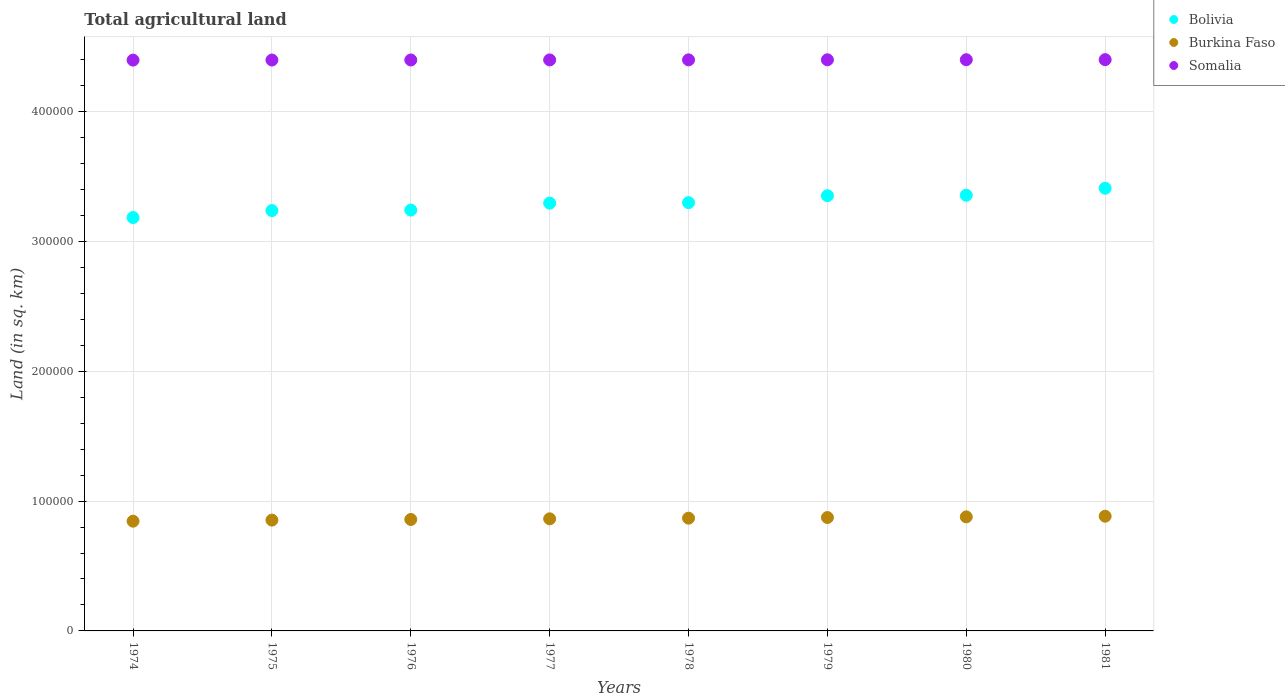How many different coloured dotlines are there?
Make the answer very short. 3. What is the total agricultural land in Somalia in 1974?
Make the answer very short. 4.40e+05. Across all years, what is the maximum total agricultural land in Bolivia?
Make the answer very short. 3.41e+05. Across all years, what is the minimum total agricultural land in Somalia?
Offer a very short reply. 4.40e+05. In which year was the total agricultural land in Somalia maximum?
Keep it short and to the point. 1981. In which year was the total agricultural land in Somalia minimum?
Ensure brevity in your answer.  1974. What is the total total agricultural land in Burkina Faso in the graph?
Offer a terse response. 6.92e+05. What is the difference between the total agricultural land in Somalia in 1975 and that in 1977?
Offer a very short reply. -100. What is the difference between the total agricultural land in Somalia in 1975 and the total agricultural land in Burkina Faso in 1974?
Make the answer very short. 3.55e+05. What is the average total agricultural land in Bolivia per year?
Your answer should be very brief. 3.30e+05. In the year 1978, what is the difference between the total agricultural land in Bolivia and total agricultural land in Somalia?
Provide a succinct answer. -1.10e+05. In how many years, is the total agricultural land in Somalia greater than 80000 sq.km?
Your answer should be compact. 8. What is the ratio of the total agricultural land in Somalia in 1975 to that in 1978?
Your response must be concise. 1. Is the difference between the total agricultural land in Bolivia in 1976 and 1980 greater than the difference between the total agricultural land in Somalia in 1976 and 1980?
Provide a short and direct response. No. What is the difference between the highest and the second highest total agricultural land in Bolivia?
Ensure brevity in your answer.  5370. What is the difference between the highest and the lowest total agricultural land in Burkina Faso?
Your answer should be very brief. 3820. Is it the case that in every year, the sum of the total agricultural land in Somalia and total agricultural land in Burkina Faso  is greater than the total agricultural land in Bolivia?
Your answer should be very brief. Yes. Is the total agricultural land in Bolivia strictly greater than the total agricultural land in Burkina Faso over the years?
Offer a very short reply. Yes. How many dotlines are there?
Keep it short and to the point. 3. How many years are there in the graph?
Your answer should be compact. 8. Are the values on the major ticks of Y-axis written in scientific E-notation?
Your answer should be compact. No. Does the graph contain any zero values?
Your answer should be very brief. No. How many legend labels are there?
Offer a very short reply. 3. What is the title of the graph?
Your response must be concise. Total agricultural land. Does "Argentina" appear as one of the legend labels in the graph?
Provide a succinct answer. No. What is the label or title of the Y-axis?
Provide a succinct answer. Land (in sq. km). What is the Land (in sq. km) of Bolivia in 1974?
Ensure brevity in your answer.  3.18e+05. What is the Land (in sq. km) of Burkina Faso in 1974?
Your answer should be compact. 8.45e+04. What is the Land (in sq. km) of Somalia in 1974?
Keep it short and to the point. 4.40e+05. What is the Land (in sq. km) of Bolivia in 1975?
Your answer should be compact. 3.24e+05. What is the Land (in sq. km) in Burkina Faso in 1975?
Your response must be concise. 8.54e+04. What is the Land (in sq. km) of Somalia in 1975?
Offer a terse response. 4.40e+05. What is the Land (in sq. km) of Bolivia in 1976?
Provide a short and direct response. 3.24e+05. What is the Land (in sq. km) of Burkina Faso in 1976?
Your answer should be compact. 8.58e+04. What is the Land (in sq. km) in Somalia in 1976?
Provide a succinct answer. 4.40e+05. What is the Land (in sq. km) in Bolivia in 1977?
Your answer should be very brief. 3.30e+05. What is the Land (in sq. km) of Burkina Faso in 1977?
Give a very brief answer. 8.64e+04. What is the Land (in sq. km) of Somalia in 1977?
Make the answer very short. 4.40e+05. What is the Land (in sq. km) in Bolivia in 1978?
Your answer should be compact. 3.30e+05. What is the Land (in sq. km) of Burkina Faso in 1978?
Offer a very short reply. 8.68e+04. What is the Land (in sq. km) in Somalia in 1978?
Provide a succinct answer. 4.40e+05. What is the Land (in sq. km) of Bolivia in 1979?
Keep it short and to the point. 3.35e+05. What is the Land (in sq. km) of Burkina Faso in 1979?
Offer a terse response. 8.74e+04. What is the Land (in sq. km) of Somalia in 1979?
Offer a very short reply. 4.40e+05. What is the Land (in sq. km) in Bolivia in 1980?
Give a very brief answer. 3.36e+05. What is the Land (in sq. km) of Burkina Faso in 1980?
Ensure brevity in your answer.  8.78e+04. What is the Land (in sq. km) in Bolivia in 1981?
Your answer should be very brief. 3.41e+05. What is the Land (in sq. km) in Burkina Faso in 1981?
Your answer should be very brief. 8.84e+04. What is the Land (in sq. km) of Somalia in 1981?
Offer a terse response. 4.40e+05. Across all years, what is the maximum Land (in sq. km) in Bolivia?
Offer a terse response. 3.41e+05. Across all years, what is the maximum Land (in sq. km) in Burkina Faso?
Provide a short and direct response. 8.84e+04. Across all years, what is the maximum Land (in sq. km) in Somalia?
Offer a terse response. 4.40e+05. Across all years, what is the minimum Land (in sq. km) of Bolivia?
Give a very brief answer. 3.18e+05. Across all years, what is the minimum Land (in sq. km) in Burkina Faso?
Ensure brevity in your answer.  8.45e+04. Across all years, what is the minimum Land (in sq. km) of Somalia?
Your response must be concise. 4.40e+05. What is the total Land (in sq. km) in Bolivia in the graph?
Provide a short and direct response. 2.64e+06. What is the total Land (in sq. km) of Burkina Faso in the graph?
Keep it short and to the point. 6.92e+05. What is the total Land (in sq. km) in Somalia in the graph?
Provide a short and direct response. 3.52e+06. What is the difference between the Land (in sq. km) in Bolivia in 1974 and that in 1975?
Your answer should be compact. -5370. What is the difference between the Land (in sq. km) of Burkina Faso in 1974 and that in 1975?
Give a very brief answer. -830. What is the difference between the Land (in sq. km) of Bolivia in 1974 and that in 1976?
Keep it short and to the point. -5730. What is the difference between the Land (in sq. km) in Burkina Faso in 1974 and that in 1976?
Keep it short and to the point. -1320. What is the difference between the Land (in sq. km) of Somalia in 1974 and that in 1976?
Keep it short and to the point. -100. What is the difference between the Land (in sq. km) in Bolivia in 1974 and that in 1977?
Provide a short and direct response. -1.11e+04. What is the difference between the Land (in sq. km) of Burkina Faso in 1974 and that in 1977?
Your answer should be very brief. -1820. What is the difference between the Land (in sq. km) in Somalia in 1974 and that in 1977?
Provide a succinct answer. -150. What is the difference between the Land (in sq. km) in Bolivia in 1974 and that in 1978?
Your answer should be very brief. -1.15e+04. What is the difference between the Land (in sq. km) of Burkina Faso in 1974 and that in 1978?
Provide a short and direct response. -2320. What is the difference between the Land (in sq. km) of Somalia in 1974 and that in 1978?
Your answer should be compact. -200. What is the difference between the Land (in sq. km) of Bolivia in 1974 and that in 1979?
Offer a terse response. -1.68e+04. What is the difference between the Land (in sq. km) in Burkina Faso in 1974 and that in 1979?
Provide a short and direct response. -2820. What is the difference between the Land (in sq. km) in Somalia in 1974 and that in 1979?
Your answer should be very brief. -250. What is the difference between the Land (in sq. km) in Bolivia in 1974 and that in 1980?
Provide a short and direct response. -1.72e+04. What is the difference between the Land (in sq. km) of Burkina Faso in 1974 and that in 1980?
Keep it short and to the point. -3320. What is the difference between the Land (in sq. km) in Somalia in 1974 and that in 1980?
Offer a very short reply. -300. What is the difference between the Land (in sq. km) in Bolivia in 1974 and that in 1981?
Offer a very short reply. -2.26e+04. What is the difference between the Land (in sq. km) in Burkina Faso in 1974 and that in 1981?
Provide a short and direct response. -3820. What is the difference between the Land (in sq. km) of Somalia in 1974 and that in 1981?
Your response must be concise. -350. What is the difference between the Land (in sq. km) of Bolivia in 1975 and that in 1976?
Give a very brief answer. -360. What is the difference between the Land (in sq. km) of Burkina Faso in 1975 and that in 1976?
Offer a terse response. -490. What is the difference between the Land (in sq. km) of Bolivia in 1975 and that in 1977?
Make the answer very short. -5730. What is the difference between the Land (in sq. km) of Burkina Faso in 1975 and that in 1977?
Offer a terse response. -990. What is the difference between the Land (in sq. km) of Somalia in 1975 and that in 1977?
Offer a very short reply. -100. What is the difference between the Land (in sq. km) in Bolivia in 1975 and that in 1978?
Make the answer very short. -6090. What is the difference between the Land (in sq. km) in Burkina Faso in 1975 and that in 1978?
Your answer should be very brief. -1490. What is the difference between the Land (in sq. km) of Somalia in 1975 and that in 1978?
Your answer should be compact. -150. What is the difference between the Land (in sq. km) of Bolivia in 1975 and that in 1979?
Give a very brief answer. -1.14e+04. What is the difference between the Land (in sq. km) in Burkina Faso in 1975 and that in 1979?
Give a very brief answer. -1990. What is the difference between the Land (in sq. km) in Somalia in 1975 and that in 1979?
Your answer should be very brief. -200. What is the difference between the Land (in sq. km) in Bolivia in 1975 and that in 1980?
Your answer should be very brief. -1.18e+04. What is the difference between the Land (in sq. km) of Burkina Faso in 1975 and that in 1980?
Give a very brief answer. -2490. What is the difference between the Land (in sq. km) of Somalia in 1975 and that in 1980?
Give a very brief answer. -250. What is the difference between the Land (in sq. km) of Bolivia in 1975 and that in 1981?
Your answer should be compact. -1.72e+04. What is the difference between the Land (in sq. km) of Burkina Faso in 1975 and that in 1981?
Give a very brief answer. -2990. What is the difference between the Land (in sq. km) of Somalia in 1975 and that in 1981?
Ensure brevity in your answer.  -300. What is the difference between the Land (in sq. km) in Bolivia in 1976 and that in 1977?
Provide a short and direct response. -5370. What is the difference between the Land (in sq. km) of Burkina Faso in 1976 and that in 1977?
Ensure brevity in your answer.  -500. What is the difference between the Land (in sq. km) of Bolivia in 1976 and that in 1978?
Your answer should be very brief. -5730. What is the difference between the Land (in sq. km) of Burkina Faso in 1976 and that in 1978?
Offer a terse response. -1000. What is the difference between the Land (in sq. km) in Somalia in 1976 and that in 1978?
Make the answer very short. -100. What is the difference between the Land (in sq. km) of Bolivia in 1976 and that in 1979?
Offer a terse response. -1.11e+04. What is the difference between the Land (in sq. km) in Burkina Faso in 1976 and that in 1979?
Offer a very short reply. -1500. What is the difference between the Land (in sq. km) of Somalia in 1976 and that in 1979?
Provide a short and direct response. -150. What is the difference between the Land (in sq. km) of Bolivia in 1976 and that in 1980?
Make the answer very short. -1.15e+04. What is the difference between the Land (in sq. km) in Burkina Faso in 1976 and that in 1980?
Your response must be concise. -2000. What is the difference between the Land (in sq. km) in Somalia in 1976 and that in 1980?
Ensure brevity in your answer.  -200. What is the difference between the Land (in sq. km) in Bolivia in 1976 and that in 1981?
Keep it short and to the point. -1.68e+04. What is the difference between the Land (in sq. km) of Burkina Faso in 1976 and that in 1981?
Your response must be concise. -2500. What is the difference between the Land (in sq. km) of Somalia in 1976 and that in 1981?
Give a very brief answer. -250. What is the difference between the Land (in sq. km) of Bolivia in 1977 and that in 1978?
Provide a succinct answer. -360. What is the difference between the Land (in sq. km) in Burkina Faso in 1977 and that in 1978?
Make the answer very short. -500. What is the difference between the Land (in sq. km) of Somalia in 1977 and that in 1978?
Give a very brief answer. -50. What is the difference between the Land (in sq. km) of Bolivia in 1977 and that in 1979?
Offer a very short reply. -5720. What is the difference between the Land (in sq. km) of Burkina Faso in 1977 and that in 1979?
Offer a very short reply. -1000. What is the difference between the Land (in sq. km) in Somalia in 1977 and that in 1979?
Provide a short and direct response. -100. What is the difference between the Land (in sq. km) of Bolivia in 1977 and that in 1980?
Your response must be concise. -6090. What is the difference between the Land (in sq. km) of Burkina Faso in 1977 and that in 1980?
Give a very brief answer. -1500. What is the difference between the Land (in sq. km) of Somalia in 1977 and that in 1980?
Keep it short and to the point. -150. What is the difference between the Land (in sq. km) in Bolivia in 1977 and that in 1981?
Your answer should be compact. -1.15e+04. What is the difference between the Land (in sq. km) in Burkina Faso in 1977 and that in 1981?
Ensure brevity in your answer.  -2000. What is the difference between the Land (in sq. km) in Somalia in 1977 and that in 1981?
Offer a very short reply. -200. What is the difference between the Land (in sq. km) of Bolivia in 1978 and that in 1979?
Ensure brevity in your answer.  -5360. What is the difference between the Land (in sq. km) in Burkina Faso in 1978 and that in 1979?
Your response must be concise. -500. What is the difference between the Land (in sq. km) in Bolivia in 1978 and that in 1980?
Provide a short and direct response. -5730. What is the difference between the Land (in sq. km) in Burkina Faso in 1978 and that in 1980?
Ensure brevity in your answer.  -1000. What is the difference between the Land (in sq. km) of Somalia in 1978 and that in 1980?
Your answer should be very brief. -100. What is the difference between the Land (in sq. km) in Bolivia in 1978 and that in 1981?
Ensure brevity in your answer.  -1.11e+04. What is the difference between the Land (in sq. km) in Burkina Faso in 1978 and that in 1981?
Ensure brevity in your answer.  -1500. What is the difference between the Land (in sq. km) of Somalia in 1978 and that in 1981?
Provide a succinct answer. -150. What is the difference between the Land (in sq. km) of Bolivia in 1979 and that in 1980?
Your answer should be very brief. -370. What is the difference between the Land (in sq. km) in Burkina Faso in 1979 and that in 1980?
Your answer should be compact. -500. What is the difference between the Land (in sq. km) of Bolivia in 1979 and that in 1981?
Your answer should be compact. -5740. What is the difference between the Land (in sq. km) of Burkina Faso in 1979 and that in 1981?
Keep it short and to the point. -1000. What is the difference between the Land (in sq. km) in Somalia in 1979 and that in 1981?
Give a very brief answer. -100. What is the difference between the Land (in sq. km) of Bolivia in 1980 and that in 1981?
Provide a succinct answer. -5370. What is the difference between the Land (in sq. km) in Burkina Faso in 1980 and that in 1981?
Keep it short and to the point. -500. What is the difference between the Land (in sq. km) of Bolivia in 1974 and the Land (in sq. km) of Burkina Faso in 1975?
Offer a terse response. 2.33e+05. What is the difference between the Land (in sq. km) of Bolivia in 1974 and the Land (in sq. km) of Somalia in 1975?
Provide a short and direct response. -1.21e+05. What is the difference between the Land (in sq. km) of Burkina Faso in 1974 and the Land (in sq. km) of Somalia in 1975?
Ensure brevity in your answer.  -3.55e+05. What is the difference between the Land (in sq. km) in Bolivia in 1974 and the Land (in sq. km) in Burkina Faso in 1976?
Offer a terse response. 2.33e+05. What is the difference between the Land (in sq. km) in Bolivia in 1974 and the Land (in sq. km) in Somalia in 1976?
Offer a terse response. -1.21e+05. What is the difference between the Land (in sq. km) of Burkina Faso in 1974 and the Land (in sq. km) of Somalia in 1976?
Provide a succinct answer. -3.55e+05. What is the difference between the Land (in sq. km) of Bolivia in 1974 and the Land (in sq. km) of Burkina Faso in 1977?
Give a very brief answer. 2.32e+05. What is the difference between the Land (in sq. km) of Bolivia in 1974 and the Land (in sq. km) of Somalia in 1977?
Your response must be concise. -1.21e+05. What is the difference between the Land (in sq. km) of Burkina Faso in 1974 and the Land (in sq. km) of Somalia in 1977?
Offer a very short reply. -3.55e+05. What is the difference between the Land (in sq. km) of Bolivia in 1974 and the Land (in sq. km) of Burkina Faso in 1978?
Make the answer very short. 2.32e+05. What is the difference between the Land (in sq. km) of Bolivia in 1974 and the Land (in sq. km) of Somalia in 1978?
Ensure brevity in your answer.  -1.21e+05. What is the difference between the Land (in sq. km) in Burkina Faso in 1974 and the Land (in sq. km) in Somalia in 1978?
Your answer should be very brief. -3.55e+05. What is the difference between the Land (in sq. km) in Bolivia in 1974 and the Land (in sq. km) in Burkina Faso in 1979?
Keep it short and to the point. 2.31e+05. What is the difference between the Land (in sq. km) in Bolivia in 1974 and the Land (in sq. km) in Somalia in 1979?
Offer a very short reply. -1.22e+05. What is the difference between the Land (in sq. km) in Burkina Faso in 1974 and the Land (in sq. km) in Somalia in 1979?
Give a very brief answer. -3.55e+05. What is the difference between the Land (in sq. km) in Bolivia in 1974 and the Land (in sq. km) in Burkina Faso in 1980?
Give a very brief answer. 2.31e+05. What is the difference between the Land (in sq. km) in Bolivia in 1974 and the Land (in sq. km) in Somalia in 1980?
Keep it short and to the point. -1.22e+05. What is the difference between the Land (in sq. km) in Burkina Faso in 1974 and the Land (in sq. km) in Somalia in 1980?
Provide a succinct answer. -3.55e+05. What is the difference between the Land (in sq. km) of Bolivia in 1974 and the Land (in sq. km) of Burkina Faso in 1981?
Keep it short and to the point. 2.30e+05. What is the difference between the Land (in sq. km) in Bolivia in 1974 and the Land (in sq. km) in Somalia in 1981?
Your answer should be very brief. -1.22e+05. What is the difference between the Land (in sq. km) in Burkina Faso in 1974 and the Land (in sq. km) in Somalia in 1981?
Make the answer very short. -3.56e+05. What is the difference between the Land (in sq. km) of Bolivia in 1975 and the Land (in sq. km) of Burkina Faso in 1976?
Ensure brevity in your answer.  2.38e+05. What is the difference between the Land (in sq. km) in Bolivia in 1975 and the Land (in sq. km) in Somalia in 1976?
Offer a terse response. -1.16e+05. What is the difference between the Land (in sq. km) in Burkina Faso in 1975 and the Land (in sq. km) in Somalia in 1976?
Offer a very short reply. -3.54e+05. What is the difference between the Land (in sq. km) of Bolivia in 1975 and the Land (in sq. km) of Burkina Faso in 1977?
Your answer should be compact. 2.37e+05. What is the difference between the Land (in sq. km) of Bolivia in 1975 and the Land (in sq. km) of Somalia in 1977?
Provide a succinct answer. -1.16e+05. What is the difference between the Land (in sq. km) of Burkina Faso in 1975 and the Land (in sq. km) of Somalia in 1977?
Ensure brevity in your answer.  -3.54e+05. What is the difference between the Land (in sq. km) of Bolivia in 1975 and the Land (in sq. km) of Burkina Faso in 1978?
Keep it short and to the point. 2.37e+05. What is the difference between the Land (in sq. km) of Bolivia in 1975 and the Land (in sq. km) of Somalia in 1978?
Your answer should be compact. -1.16e+05. What is the difference between the Land (in sq. km) of Burkina Faso in 1975 and the Land (in sq. km) of Somalia in 1978?
Provide a succinct answer. -3.55e+05. What is the difference between the Land (in sq. km) in Bolivia in 1975 and the Land (in sq. km) in Burkina Faso in 1979?
Offer a very short reply. 2.36e+05. What is the difference between the Land (in sq. km) of Bolivia in 1975 and the Land (in sq. km) of Somalia in 1979?
Offer a very short reply. -1.16e+05. What is the difference between the Land (in sq. km) of Burkina Faso in 1975 and the Land (in sq. km) of Somalia in 1979?
Provide a short and direct response. -3.55e+05. What is the difference between the Land (in sq. km) of Bolivia in 1975 and the Land (in sq. km) of Burkina Faso in 1980?
Your response must be concise. 2.36e+05. What is the difference between the Land (in sq. km) in Bolivia in 1975 and the Land (in sq. km) in Somalia in 1980?
Ensure brevity in your answer.  -1.16e+05. What is the difference between the Land (in sq. km) in Burkina Faso in 1975 and the Land (in sq. km) in Somalia in 1980?
Provide a short and direct response. -3.55e+05. What is the difference between the Land (in sq. km) in Bolivia in 1975 and the Land (in sq. km) in Burkina Faso in 1981?
Provide a succinct answer. 2.35e+05. What is the difference between the Land (in sq. km) in Bolivia in 1975 and the Land (in sq. km) in Somalia in 1981?
Your answer should be very brief. -1.16e+05. What is the difference between the Land (in sq. km) in Burkina Faso in 1975 and the Land (in sq. km) in Somalia in 1981?
Offer a very short reply. -3.55e+05. What is the difference between the Land (in sq. km) of Bolivia in 1976 and the Land (in sq. km) of Burkina Faso in 1977?
Offer a very short reply. 2.38e+05. What is the difference between the Land (in sq. km) of Bolivia in 1976 and the Land (in sq. km) of Somalia in 1977?
Your response must be concise. -1.16e+05. What is the difference between the Land (in sq. km) in Burkina Faso in 1976 and the Land (in sq. km) in Somalia in 1977?
Give a very brief answer. -3.54e+05. What is the difference between the Land (in sq. km) of Bolivia in 1976 and the Land (in sq. km) of Burkina Faso in 1978?
Provide a short and direct response. 2.37e+05. What is the difference between the Land (in sq. km) of Bolivia in 1976 and the Land (in sq. km) of Somalia in 1978?
Your answer should be compact. -1.16e+05. What is the difference between the Land (in sq. km) of Burkina Faso in 1976 and the Land (in sq. km) of Somalia in 1978?
Offer a very short reply. -3.54e+05. What is the difference between the Land (in sq. km) in Bolivia in 1976 and the Land (in sq. km) in Burkina Faso in 1979?
Make the answer very short. 2.37e+05. What is the difference between the Land (in sq. km) in Bolivia in 1976 and the Land (in sq. km) in Somalia in 1979?
Provide a short and direct response. -1.16e+05. What is the difference between the Land (in sq. km) in Burkina Faso in 1976 and the Land (in sq. km) in Somalia in 1979?
Ensure brevity in your answer.  -3.54e+05. What is the difference between the Land (in sq. km) in Bolivia in 1976 and the Land (in sq. km) in Burkina Faso in 1980?
Ensure brevity in your answer.  2.36e+05. What is the difference between the Land (in sq. km) in Bolivia in 1976 and the Land (in sq. km) in Somalia in 1980?
Offer a very short reply. -1.16e+05. What is the difference between the Land (in sq. km) of Burkina Faso in 1976 and the Land (in sq. km) of Somalia in 1980?
Give a very brief answer. -3.54e+05. What is the difference between the Land (in sq. km) of Bolivia in 1976 and the Land (in sq. km) of Burkina Faso in 1981?
Ensure brevity in your answer.  2.36e+05. What is the difference between the Land (in sq. km) of Bolivia in 1976 and the Land (in sq. km) of Somalia in 1981?
Your answer should be very brief. -1.16e+05. What is the difference between the Land (in sq. km) in Burkina Faso in 1976 and the Land (in sq. km) in Somalia in 1981?
Offer a very short reply. -3.54e+05. What is the difference between the Land (in sq. km) in Bolivia in 1977 and the Land (in sq. km) in Burkina Faso in 1978?
Your answer should be very brief. 2.43e+05. What is the difference between the Land (in sq. km) in Bolivia in 1977 and the Land (in sq. km) in Somalia in 1978?
Your answer should be very brief. -1.10e+05. What is the difference between the Land (in sq. km) in Burkina Faso in 1977 and the Land (in sq. km) in Somalia in 1978?
Provide a short and direct response. -3.54e+05. What is the difference between the Land (in sq. km) of Bolivia in 1977 and the Land (in sq. km) of Burkina Faso in 1979?
Ensure brevity in your answer.  2.42e+05. What is the difference between the Land (in sq. km) of Bolivia in 1977 and the Land (in sq. km) of Somalia in 1979?
Give a very brief answer. -1.10e+05. What is the difference between the Land (in sq. km) in Burkina Faso in 1977 and the Land (in sq. km) in Somalia in 1979?
Offer a terse response. -3.54e+05. What is the difference between the Land (in sq. km) in Bolivia in 1977 and the Land (in sq. km) in Burkina Faso in 1980?
Make the answer very short. 2.42e+05. What is the difference between the Land (in sq. km) of Bolivia in 1977 and the Land (in sq. km) of Somalia in 1980?
Ensure brevity in your answer.  -1.10e+05. What is the difference between the Land (in sq. km) of Burkina Faso in 1977 and the Land (in sq. km) of Somalia in 1980?
Make the answer very short. -3.54e+05. What is the difference between the Land (in sq. km) of Bolivia in 1977 and the Land (in sq. km) of Burkina Faso in 1981?
Give a very brief answer. 2.41e+05. What is the difference between the Land (in sq. km) in Bolivia in 1977 and the Land (in sq. km) in Somalia in 1981?
Make the answer very short. -1.11e+05. What is the difference between the Land (in sq. km) of Burkina Faso in 1977 and the Land (in sq. km) of Somalia in 1981?
Keep it short and to the point. -3.54e+05. What is the difference between the Land (in sq. km) in Bolivia in 1978 and the Land (in sq. km) in Burkina Faso in 1979?
Your answer should be compact. 2.43e+05. What is the difference between the Land (in sq. km) in Bolivia in 1978 and the Land (in sq. km) in Somalia in 1979?
Keep it short and to the point. -1.10e+05. What is the difference between the Land (in sq. km) of Burkina Faso in 1978 and the Land (in sq. km) of Somalia in 1979?
Provide a succinct answer. -3.53e+05. What is the difference between the Land (in sq. km) in Bolivia in 1978 and the Land (in sq. km) in Burkina Faso in 1980?
Offer a very short reply. 2.42e+05. What is the difference between the Land (in sq. km) in Bolivia in 1978 and the Land (in sq. km) in Somalia in 1980?
Keep it short and to the point. -1.10e+05. What is the difference between the Land (in sq. km) of Burkina Faso in 1978 and the Land (in sq. km) of Somalia in 1980?
Provide a short and direct response. -3.53e+05. What is the difference between the Land (in sq. km) of Bolivia in 1978 and the Land (in sq. km) of Burkina Faso in 1981?
Give a very brief answer. 2.42e+05. What is the difference between the Land (in sq. km) of Bolivia in 1978 and the Land (in sq. km) of Somalia in 1981?
Your response must be concise. -1.10e+05. What is the difference between the Land (in sq. km) of Burkina Faso in 1978 and the Land (in sq. km) of Somalia in 1981?
Your response must be concise. -3.53e+05. What is the difference between the Land (in sq. km) of Bolivia in 1979 and the Land (in sq. km) of Burkina Faso in 1980?
Offer a very short reply. 2.47e+05. What is the difference between the Land (in sq. km) in Bolivia in 1979 and the Land (in sq. km) in Somalia in 1980?
Offer a terse response. -1.05e+05. What is the difference between the Land (in sq. km) in Burkina Faso in 1979 and the Land (in sq. km) in Somalia in 1980?
Your answer should be compact. -3.53e+05. What is the difference between the Land (in sq. km) in Bolivia in 1979 and the Land (in sq. km) in Burkina Faso in 1981?
Provide a succinct answer. 2.47e+05. What is the difference between the Land (in sq. km) of Bolivia in 1979 and the Land (in sq. km) of Somalia in 1981?
Ensure brevity in your answer.  -1.05e+05. What is the difference between the Land (in sq. km) of Burkina Faso in 1979 and the Land (in sq. km) of Somalia in 1981?
Your answer should be compact. -3.53e+05. What is the difference between the Land (in sq. km) of Bolivia in 1980 and the Land (in sq. km) of Burkina Faso in 1981?
Provide a short and direct response. 2.47e+05. What is the difference between the Land (in sq. km) in Bolivia in 1980 and the Land (in sq. km) in Somalia in 1981?
Your answer should be compact. -1.04e+05. What is the difference between the Land (in sq. km) in Burkina Faso in 1980 and the Land (in sq. km) in Somalia in 1981?
Your answer should be very brief. -3.52e+05. What is the average Land (in sq. km) in Bolivia per year?
Give a very brief answer. 3.30e+05. What is the average Land (in sq. km) in Burkina Faso per year?
Your answer should be very brief. 8.66e+04. What is the average Land (in sq. km) in Somalia per year?
Your response must be concise. 4.40e+05. In the year 1974, what is the difference between the Land (in sq. km) of Bolivia and Land (in sq. km) of Burkina Faso?
Your answer should be very brief. 2.34e+05. In the year 1974, what is the difference between the Land (in sq. km) of Bolivia and Land (in sq. km) of Somalia?
Provide a short and direct response. -1.21e+05. In the year 1974, what is the difference between the Land (in sq. km) of Burkina Faso and Land (in sq. km) of Somalia?
Provide a succinct answer. -3.55e+05. In the year 1975, what is the difference between the Land (in sq. km) in Bolivia and Land (in sq. km) in Burkina Faso?
Offer a very short reply. 2.38e+05. In the year 1975, what is the difference between the Land (in sq. km) of Bolivia and Land (in sq. km) of Somalia?
Your answer should be compact. -1.16e+05. In the year 1975, what is the difference between the Land (in sq. km) in Burkina Faso and Land (in sq. km) in Somalia?
Your response must be concise. -3.54e+05. In the year 1976, what is the difference between the Land (in sq. km) of Bolivia and Land (in sq. km) of Burkina Faso?
Keep it short and to the point. 2.38e+05. In the year 1976, what is the difference between the Land (in sq. km) of Bolivia and Land (in sq. km) of Somalia?
Provide a short and direct response. -1.16e+05. In the year 1976, what is the difference between the Land (in sq. km) in Burkina Faso and Land (in sq. km) in Somalia?
Keep it short and to the point. -3.54e+05. In the year 1977, what is the difference between the Land (in sq. km) in Bolivia and Land (in sq. km) in Burkina Faso?
Your answer should be compact. 2.43e+05. In the year 1977, what is the difference between the Land (in sq. km) in Bolivia and Land (in sq. km) in Somalia?
Ensure brevity in your answer.  -1.10e+05. In the year 1977, what is the difference between the Land (in sq. km) in Burkina Faso and Land (in sq. km) in Somalia?
Provide a short and direct response. -3.54e+05. In the year 1978, what is the difference between the Land (in sq. km) in Bolivia and Land (in sq. km) in Burkina Faso?
Provide a succinct answer. 2.43e+05. In the year 1978, what is the difference between the Land (in sq. km) of Bolivia and Land (in sq. km) of Somalia?
Give a very brief answer. -1.10e+05. In the year 1978, what is the difference between the Land (in sq. km) in Burkina Faso and Land (in sq. km) in Somalia?
Provide a short and direct response. -3.53e+05. In the year 1979, what is the difference between the Land (in sq. km) in Bolivia and Land (in sq. km) in Burkina Faso?
Provide a succinct answer. 2.48e+05. In the year 1979, what is the difference between the Land (in sq. km) in Bolivia and Land (in sq. km) in Somalia?
Offer a very short reply. -1.05e+05. In the year 1979, what is the difference between the Land (in sq. km) of Burkina Faso and Land (in sq. km) of Somalia?
Give a very brief answer. -3.53e+05. In the year 1980, what is the difference between the Land (in sq. km) of Bolivia and Land (in sq. km) of Burkina Faso?
Ensure brevity in your answer.  2.48e+05. In the year 1980, what is the difference between the Land (in sq. km) of Bolivia and Land (in sq. km) of Somalia?
Make the answer very short. -1.04e+05. In the year 1980, what is the difference between the Land (in sq. km) of Burkina Faso and Land (in sq. km) of Somalia?
Offer a terse response. -3.52e+05. In the year 1981, what is the difference between the Land (in sq. km) of Bolivia and Land (in sq. km) of Burkina Faso?
Keep it short and to the point. 2.53e+05. In the year 1981, what is the difference between the Land (in sq. km) in Bolivia and Land (in sq. km) in Somalia?
Provide a short and direct response. -9.91e+04. In the year 1981, what is the difference between the Land (in sq. km) of Burkina Faso and Land (in sq. km) of Somalia?
Provide a succinct answer. -3.52e+05. What is the ratio of the Land (in sq. km) of Bolivia in 1974 to that in 1975?
Offer a very short reply. 0.98. What is the ratio of the Land (in sq. km) of Burkina Faso in 1974 to that in 1975?
Ensure brevity in your answer.  0.99. What is the ratio of the Land (in sq. km) of Bolivia in 1974 to that in 1976?
Make the answer very short. 0.98. What is the ratio of the Land (in sq. km) in Burkina Faso in 1974 to that in 1976?
Your response must be concise. 0.98. What is the ratio of the Land (in sq. km) of Somalia in 1974 to that in 1976?
Ensure brevity in your answer.  1. What is the ratio of the Land (in sq. km) of Bolivia in 1974 to that in 1977?
Give a very brief answer. 0.97. What is the ratio of the Land (in sq. km) of Burkina Faso in 1974 to that in 1977?
Offer a very short reply. 0.98. What is the ratio of the Land (in sq. km) in Bolivia in 1974 to that in 1978?
Give a very brief answer. 0.97. What is the ratio of the Land (in sq. km) of Burkina Faso in 1974 to that in 1978?
Make the answer very short. 0.97. What is the ratio of the Land (in sq. km) of Bolivia in 1974 to that in 1979?
Give a very brief answer. 0.95. What is the ratio of the Land (in sq. km) in Burkina Faso in 1974 to that in 1979?
Provide a succinct answer. 0.97. What is the ratio of the Land (in sq. km) of Bolivia in 1974 to that in 1980?
Ensure brevity in your answer.  0.95. What is the ratio of the Land (in sq. km) in Burkina Faso in 1974 to that in 1980?
Your response must be concise. 0.96. What is the ratio of the Land (in sq. km) in Bolivia in 1974 to that in 1981?
Offer a terse response. 0.93. What is the ratio of the Land (in sq. km) of Burkina Faso in 1974 to that in 1981?
Provide a short and direct response. 0.96. What is the ratio of the Land (in sq. km) of Burkina Faso in 1975 to that in 1976?
Ensure brevity in your answer.  0.99. What is the ratio of the Land (in sq. km) of Bolivia in 1975 to that in 1977?
Make the answer very short. 0.98. What is the ratio of the Land (in sq. km) in Burkina Faso in 1975 to that in 1977?
Provide a short and direct response. 0.99. What is the ratio of the Land (in sq. km) in Somalia in 1975 to that in 1977?
Offer a very short reply. 1. What is the ratio of the Land (in sq. km) in Bolivia in 1975 to that in 1978?
Keep it short and to the point. 0.98. What is the ratio of the Land (in sq. km) of Burkina Faso in 1975 to that in 1978?
Offer a very short reply. 0.98. What is the ratio of the Land (in sq. km) of Bolivia in 1975 to that in 1979?
Offer a very short reply. 0.97. What is the ratio of the Land (in sq. km) in Burkina Faso in 1975 to that in 1979?
Ensure brevity in your answer.  0.98. What is the ratio of the Land (in sq. km) in Somalia in 1975 to that in 1979?
Provide a short and direct response. 1. What is the ratio of the Land (in sq. km) of Bolivia in 1975 to that in 1980?
Provide a succinct answer. 0.96. What is the ratio of the Land (in sq. km) in Burkina Faso in 1975 to that in 1980?
Your answer should be very brief. 0.97. What is the ratio of the Land (in sq. km) of Somalia in 1975 to that in 1980?
Your answer should be compact. 1. What is the ratio of the Land (in sq. km) in Bolivia in 1975 to that in 1981?
Keep it short and to the point. 0.95. What is the ratio of the Land (in sq. km) in Burkina Faso in 1975 to that in 1981?
Your answer should be compact. 0.97. What is the ratio of the Land (in sq. km) in Somalia in 1975 to that in 1981?
Give a very brief answer. 1. What is the ratio of the Land (in sq. km) in Bolivia in 1976 to that in 1977?
Offer a terse response. 0.98. What is the ratio of the Land (in sq. km) of Burkina Faso in 1976 to that in 1977?
Keep it short and to the point. 0.99. What is the ratio of the Land (in sq. km) in Bolivia in 1976 to that in 1978?
Provide a succinct answer. 0.98. What is the ratio of the Land (in sq. km) of Somalia in 1976 to that in 1978?
Provide a succinct answer. 1. What is the ratio of the Land (in sq. km) in Bolivia in 1976 to that in 1979?
Offer a very short reply. 0.97. What is the ratio of the Land (in sq. km) of Burkina Faso in 1976 to that in 1979?
Your response must be concise. 0.98. What is the ratio of the Land (in sq. km) in Bolivia in 1976 to that in 1980?
Give a very brief answer. 0.97. What is the ratio of the Land (in sq. km) in Burkina Faso in 1976 to that in 1980?
Offer a very short reply. 0.98. What is the ratio of the Land (in sq. km) of Somalia in 1976 to that in 1980?
Your answer should be compact. 1. What is the ratio of the Land (in sq. km) in Bolivia in 1976 to that in 1981?
Keep it short and to the point. 0.95. What is the ratio of the Land (in sq. km) in Burkina Faso in 1976 to that in 1981?
Ensure brevity in your answer.  0.97. What is the ratio of the Land (in sq. km) of Somalia in 1976 to that in 1981?
Your response must be concise. 1. What is the ratio of the Land (in sq. km) of Bolivia in 1977 to that in 1978?
Make the answer very short. 1. What is the ratio of the Land (in sq. km) in Burkina Faso in 1977 to that in 1978?
Offer a very short reply. 0.99. What is the ratio of the Land (in sq. km) in Bolivia in 1977 to that in 1979?
Offer a very short reply. 0.98. What is the ratio of the Land (in sq. km) in Bolivia in 1977 to that in 1980?
Provide a succinct answer. 0.98. What is the ratio of the Land (in sq. km) in Burkina Faso in 1977 to that in 1980?
Give a very brief answer. 0.98. What is the ratio of the Land (in sq. km) in Bolivia in 1977 to that in 1981?
Keep it short and to the point. 0.97. What is the ratio of the Land (in sq. km) in Burkina Faso in 1977 to that in 1981?
Make the answer very short. 0.98. What is the ratio of the Land (in sq. km) of Burkina Faso in 1978 to that in 1979?
Offer a terse response. 0.99. What is the ratio of the Land (in sq. km) in Somalia in 1978 to that in 1979?
Provide a short and direct response. 1. What is the ratio of the Land (in sq. km) in Bolivia in 1978 to that in 1980?
Ensure brevity in your answer.  0.98. What is the ratio of the Land (in sq. km) of Burkina Faso in 1978 to that in 1980?
Provide a succinct answer. 0.99. What is the ratio of the Land (in sq. km) of Bolivia in 1978 to that in 1981?
Provide a succinct answer. 0.97. What is the ratio of the Land (in sq. km) of Bolivia in 1979 to that in 1980?
Your answer should be compact. 1. What is the ratio of the Land (in sq. km) in Burkina Faso in 1979 to that in 1980?
Your response must be concise. 0.99. What is the ratio of the Land (in sq. km) of Bolivia in 1979 to that in 1981?
Make the answer very short. 0.98. What is the ratio of the Land (in sq. km) of Burkina Faso in 1979 to that in 1981?
Keep it short and to the point. 0.99. What is the ratio of the Land (in sq. km) of Somalia in 1979 to that in 1981?
Your response must be concise. 1. What is the ratio of the Land (in sq. km) of Bolivia in 1980 to that in 1981?
Your answer should be very brief. 0.98. What is the ratio of the Land (in sq. km) in Burkina Faso in 1980 to that in 1981?
Provide a succinct answer. 0.99. What is the ratio of the Land (in sq. km) in Somalia in 1980 to that in 1981?
Give a very brief answer. 1. What is the difference between the highest and the second highest Land (in sq. km) in Bolivia?
Ensure brevity in your answer.  5370. What is the difference between the highest and the second highest Land (in sq. km) of Somalia?
Keep it short and to the point. 50. What is the difference between the highest and the lowest Land (in sq. km) in Bolivia?
Provide a succinct answer. 2.26e+04. What is the difference between the highest and the lowest Land (in sq. km) of Burkina Faso?
Offer a terse response. 3820. What is the difference between the highest and the lowest Land (in sq. km) of Somalia?
Offer a terse response. 350. 